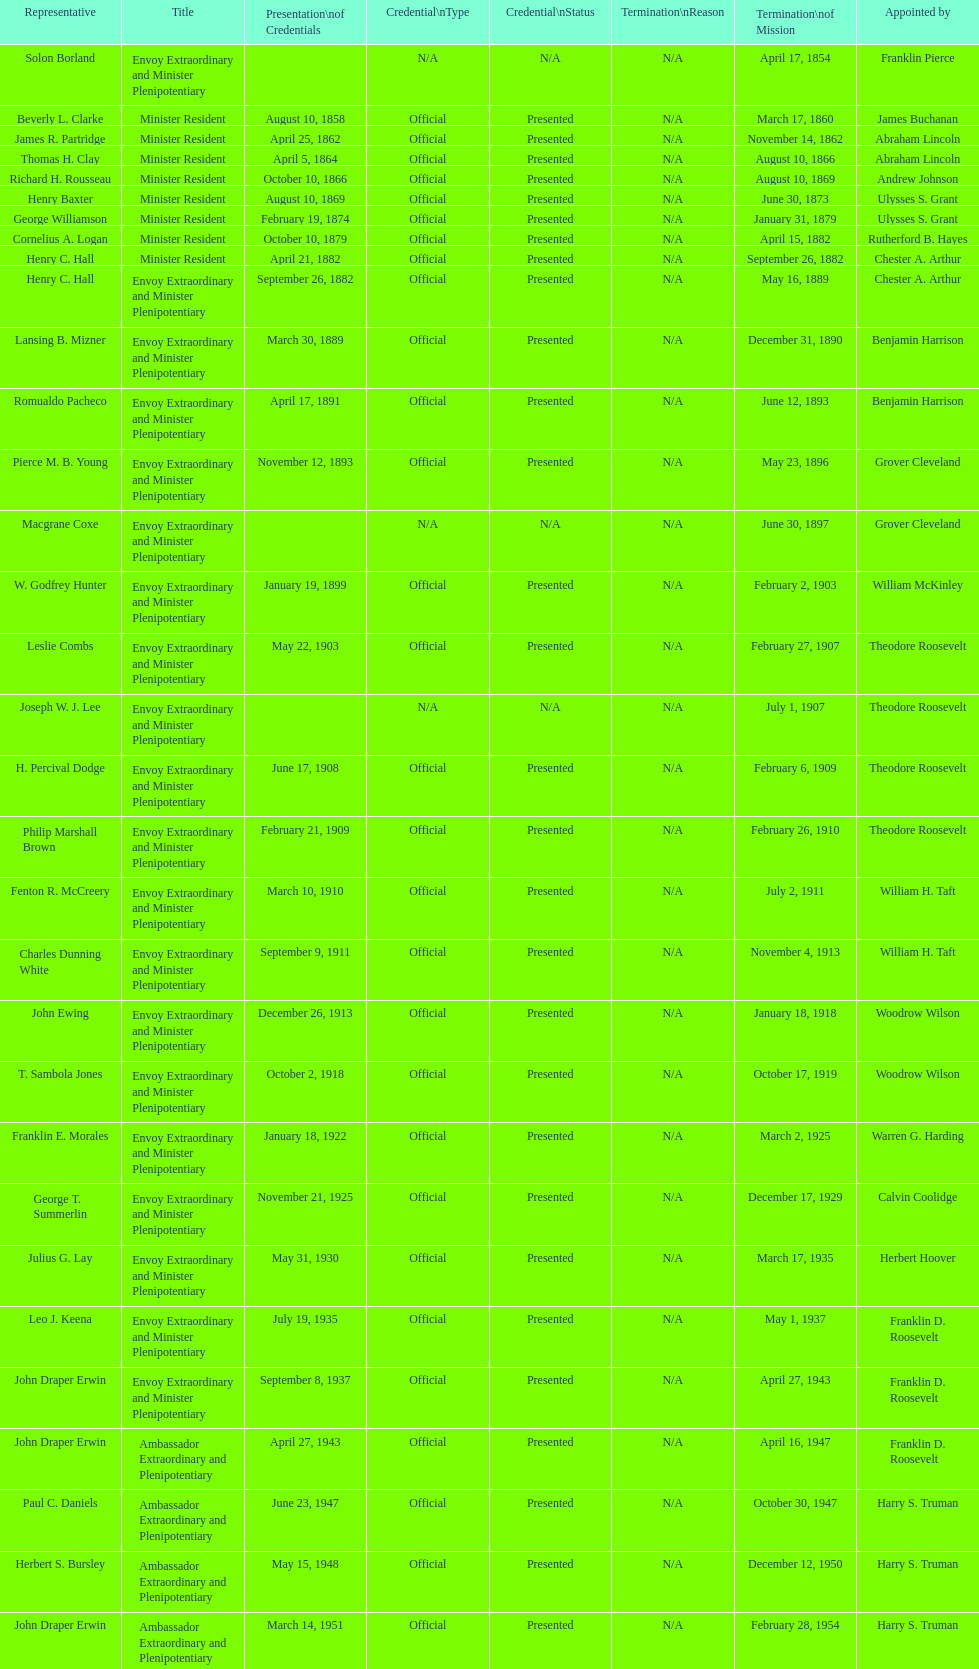Is solon borland a representative? Yes. 